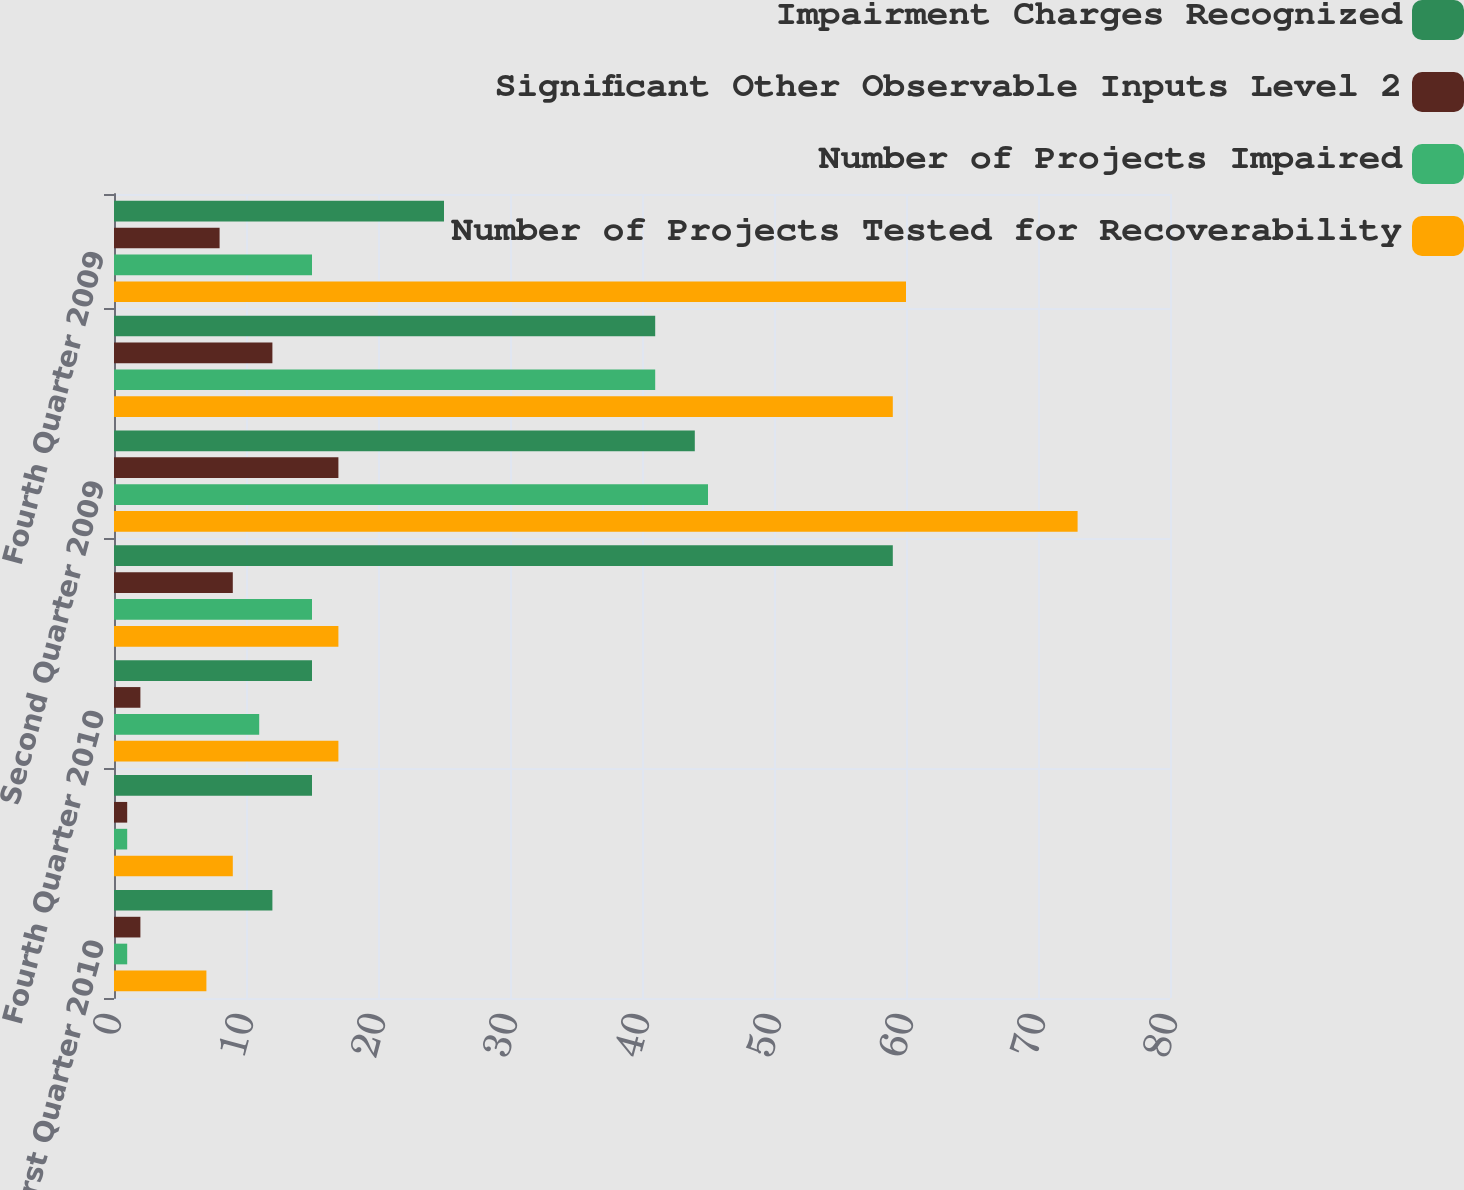Convert chart to OTSL. <chart><loc_0><loc_0><loc_500><loc_500><stacked_bar_chart><ecel><fcel>First Quarter 2010<fcel>Second Quarter 2010<fcel>Fourth Quarter 2010<fcel>First Quarter 2009<fcel>Second Quarter 2009<fcel>Third Quarter 2009<fcel>Fourth Quarter 2009<nl><fcel>Impairment Charges Recognized<fcel>12<fcel>15<fcel>15<fcel>59<fcel>44<fcel>41<fcel>25<nl><fcel>Significant Other Observable Inputs Level 2<fcel>2<fcel>1<fcel>2<fcel>9<fcel>17<fcel>12<fcel>8<nl><fcel>Number of Projects Impaired<fcel>1<fcel>1<fcel>11<fcel>15<fcel>45<fcel>41<fcel>15<nl><fcel>Number of Projects Tested for Recoverability<fcel>7<fcel>9<fcel>17<fcel>17<fcel>73<fcel>59<fcel>60<nl></chart> 